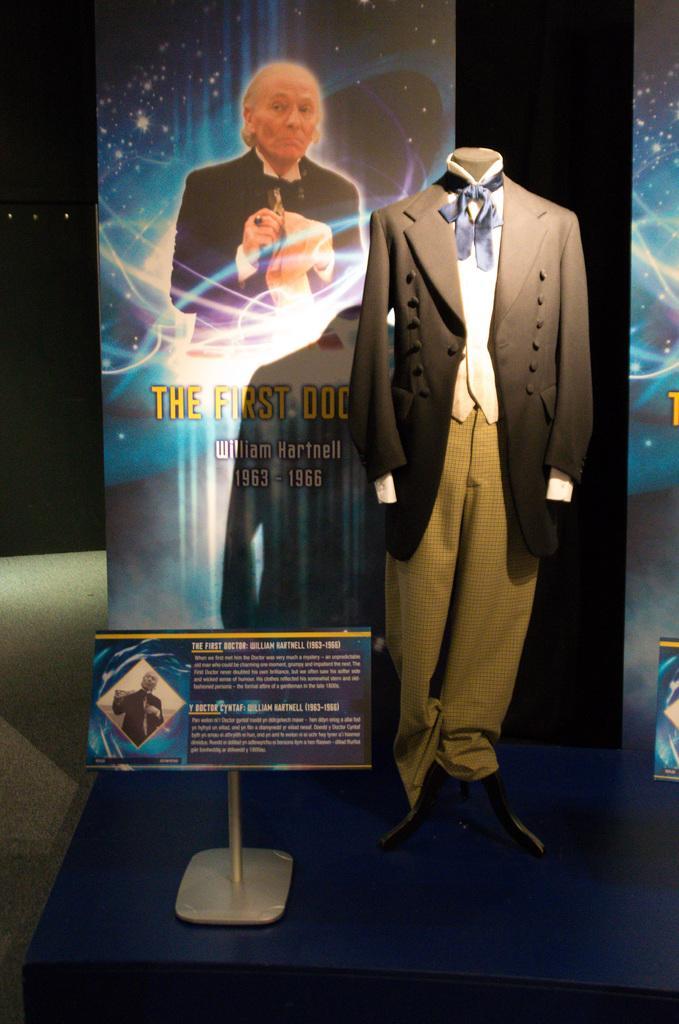Could you give a brief overview of what you see in this image? In this picture we can see clothes and a mannequin, in front of the mannequin we can see a board, in the background we can find hoardings. 